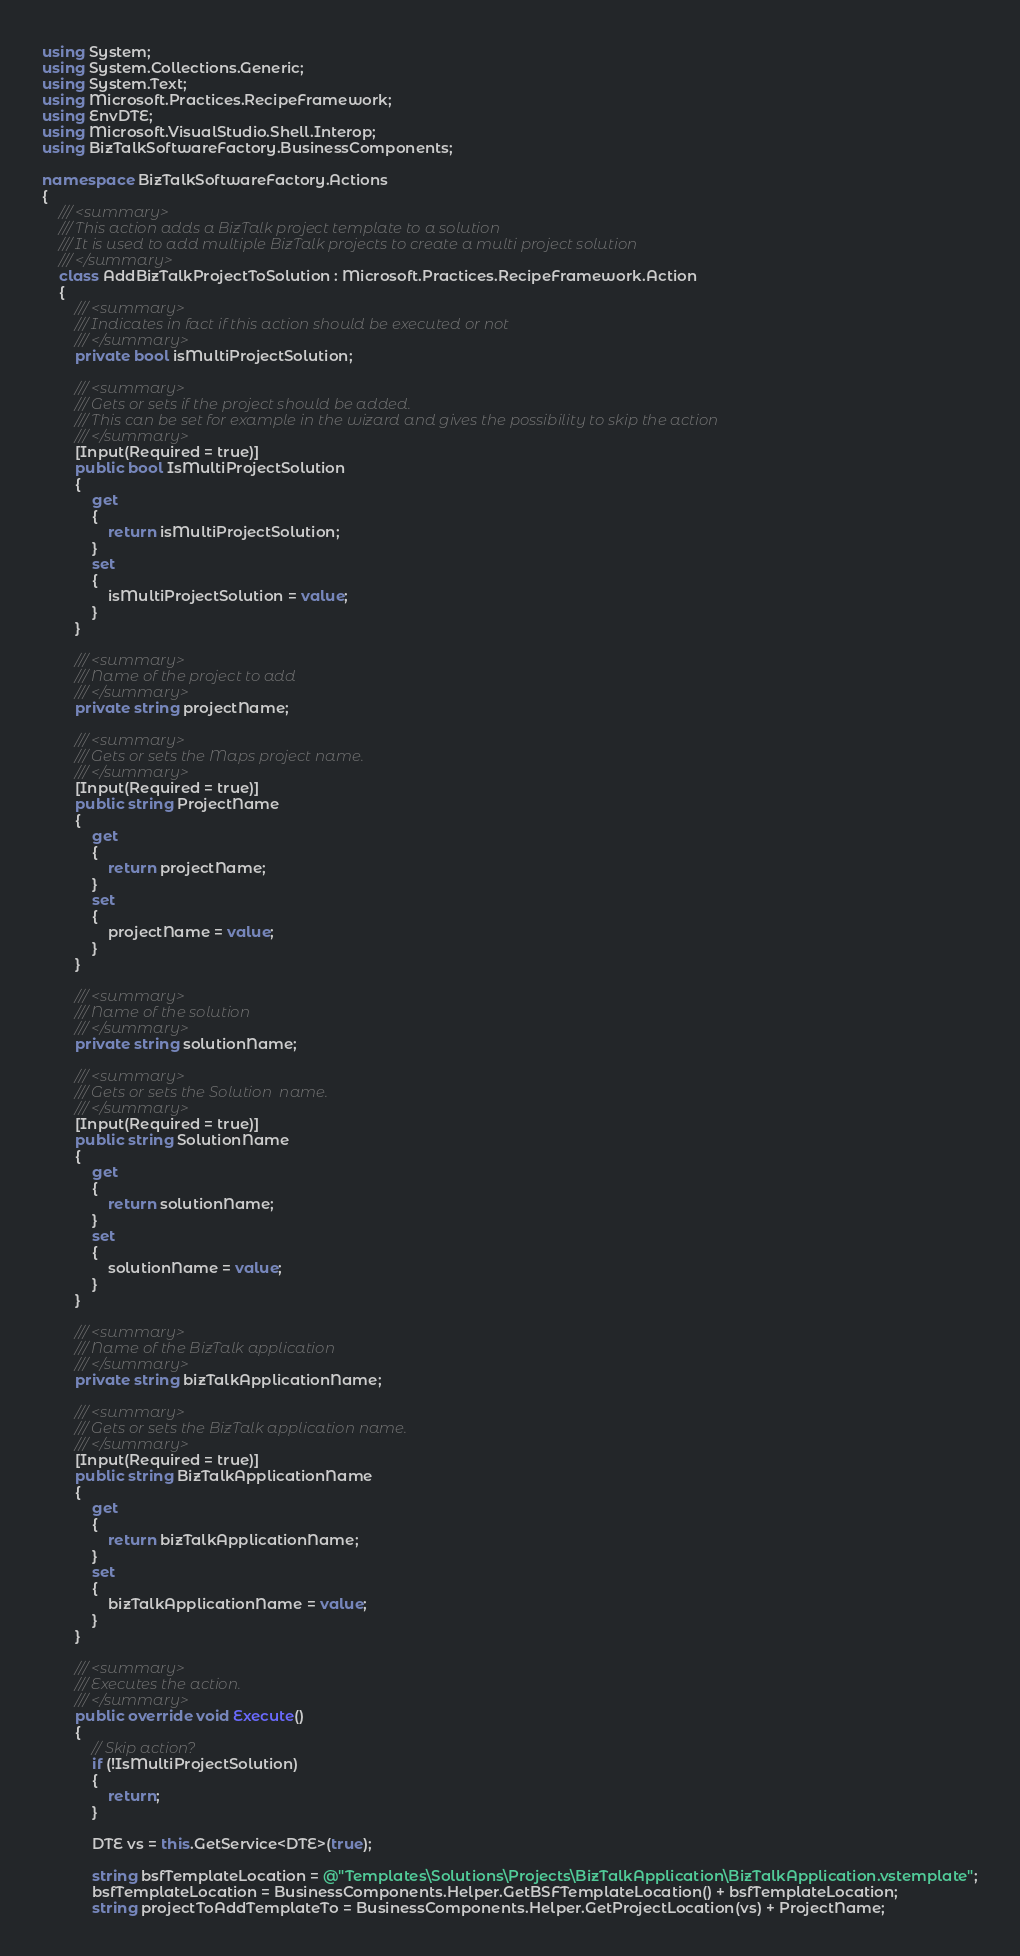Convert code to text. <code><loc_0><loc_0><loc_500><loc_500><_C#_>using System;
using System.Collections.Generic;
using System.Text;
using Microsoft.Practices.RecipeFramework;
using EnvDTE;
using Microsoft.VisualStudio.Shell.Interop;
using BizTalkSoftwareFactory.BusinessComponents;

namespace BizTalkSoftwareFactory.Actions
{
    /// <summary>
    /// This action adds a BizTalk project template to a solution
    /// It is used to add multiple BizTalk projects to create a multi project solution
    /// </summary>
    class AddBizTalkProjectToSolution : Microsoft.Practices.RecipeFramework.Action
    {
        /// <summary>
        /// Indicates in fact if this action should be executed or not
        /// </summary>
        private bool isMultiProjectSolution;

        /// <summary>
        /// Gets or sets if the project should be added.
        /// This can be set for example in the wizard and gives the possibility to skip the action
        /// </summary>
        [Input(Required = true)]
        public bool IsMultiProjectSolution
        {
            get
            {
                return isMultiProjectSolution;
            }
            set
            {
                isMultiProjectSolution = value;
            }
        }

        /// <summary>
        /// Name of the project to add
        /// </summary>
        private string projectName;

        /// <summary>
        /// Gets or sets the Maps project name.
        /// </summary>
        [Input(Required = true)]
        public string ProjectName
        {
            get
            {
                return projectName;
            }
            set
            {
                projectName = value;
            }
        }

        /// <summary>
        /// Name of the solution
        /// </summary>
        private string solutionName;

        /// <summary>
        /// Gets or sets the Solution  name.
        /// </summary>
        [Input(Required = true)]
        public string SolutionName
        {
            get
            {
                return solutionName;
            }
            set
            {
                solutionName = value;
            }
        }

        /// <summary>
        /// Name of the BizTalk application
        /// </summary>
        private string bizTalkApplicationName;

        /// <summary>
        /// Gets or sets the BizTalk application name.
        /// </summary>
        [Input(Required = true)]
        public string BizTalkApplicationName
        {
            get
            {
                return bizTalkApplicationName;
            }
            set
            {
                bizTalkApplicationName = value;
            }
        }

        /// <summary>
        /// Executes the action.
        /// </summary>
        public override void Execute()
        {
            // Skip action?
            if (!IsMultiProjectSolution)
            {
                return;
            }

            DTE vs = this.GetService<DTE>(true);

            string bsfTemplateLocation = @"Templates\Solutions\Projects\BizTalkApplication\BizTalkApplication.vstemplate";
            bsfTemplateLocation = BusinessComponents.Helper.GetBSFTemplateLocation() + bsfTemplateLocation;
            string projectToAddTemplateTo = BusinessComponents.Helper.GetProjectLocation(vs) + ProjectName;
</code> 